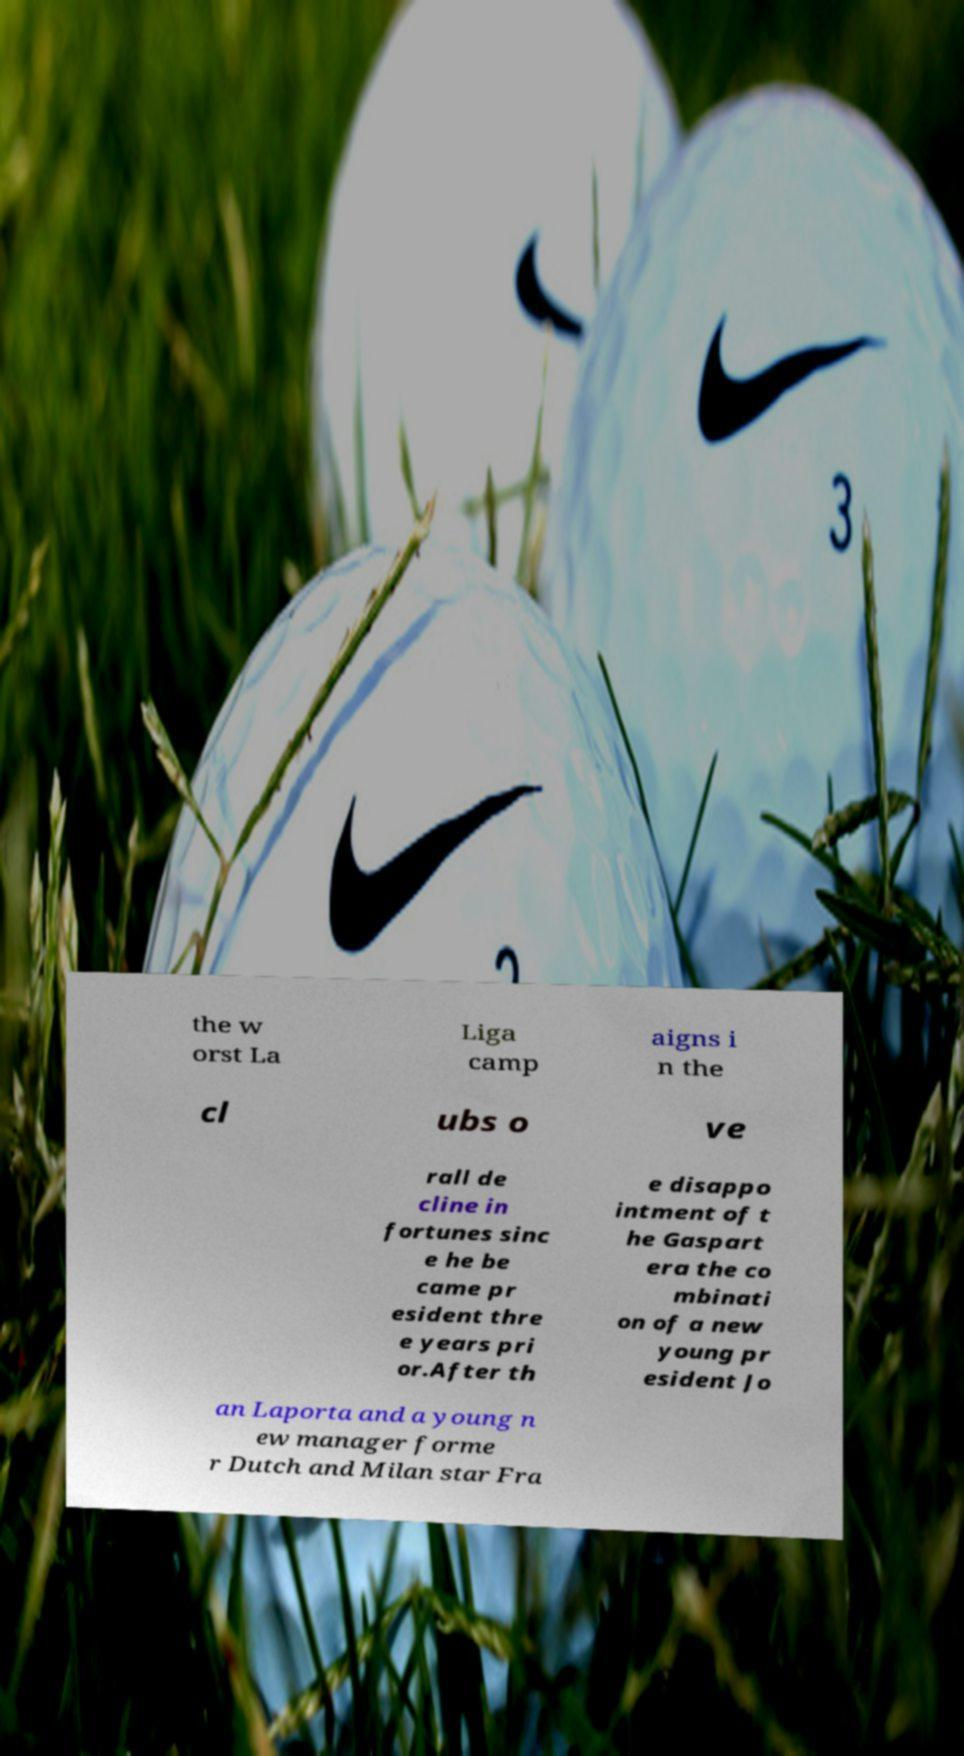For documentation purposes, I need the text within this image transcribed. Could you provide that? the w orst La Liga camp aigns i n the cl ubs o ve rall de cline in fortunes sinc e he be came pr esident thre e years pri or.After th e disappo intment of t he Gaspart era the co mbinati on of a new young pr esident Jo an Laporta and a young n ew manager forme r Dutch and Milan star Fra 